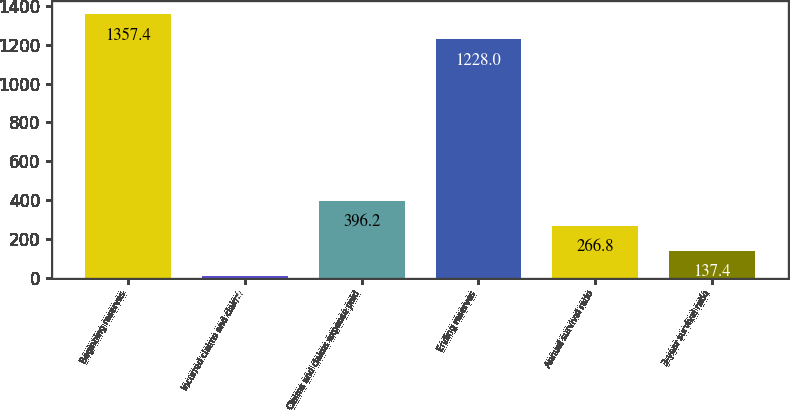<chart> <loc_0><loc_0><loc_500><loc_500><bar_chart><fcel>Beginning reserves<fcel>Incurred claims and claims<fcel>Claims and claims expense paid<fcel>Ending reserves<fcel>Annual survival ratio<fcel>3-year survival ratio<nl><fcel>1357.4<fcel>8<fcel>396.2<fcel>1228<fcel>266.8<fcel>137.4<nl></chart> 